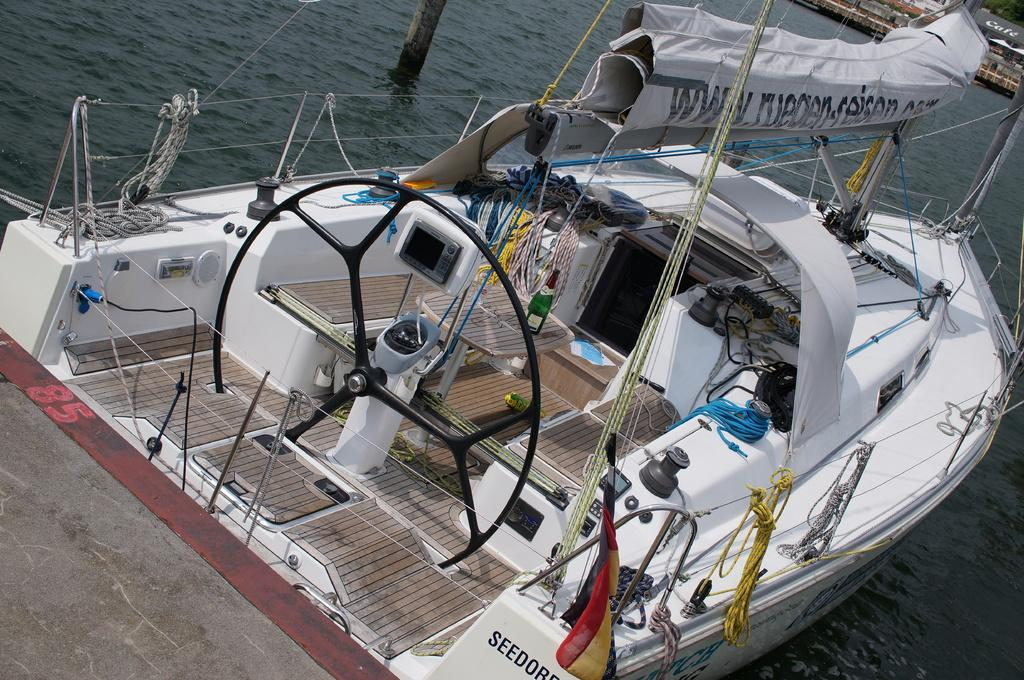What is the main subject of the image? The main subject of the image is a boat. Where is the boat located? The boat is in water. What type of crate is visible on the land in the image? There is no crate or land present in the image; it only features a boat in water. 